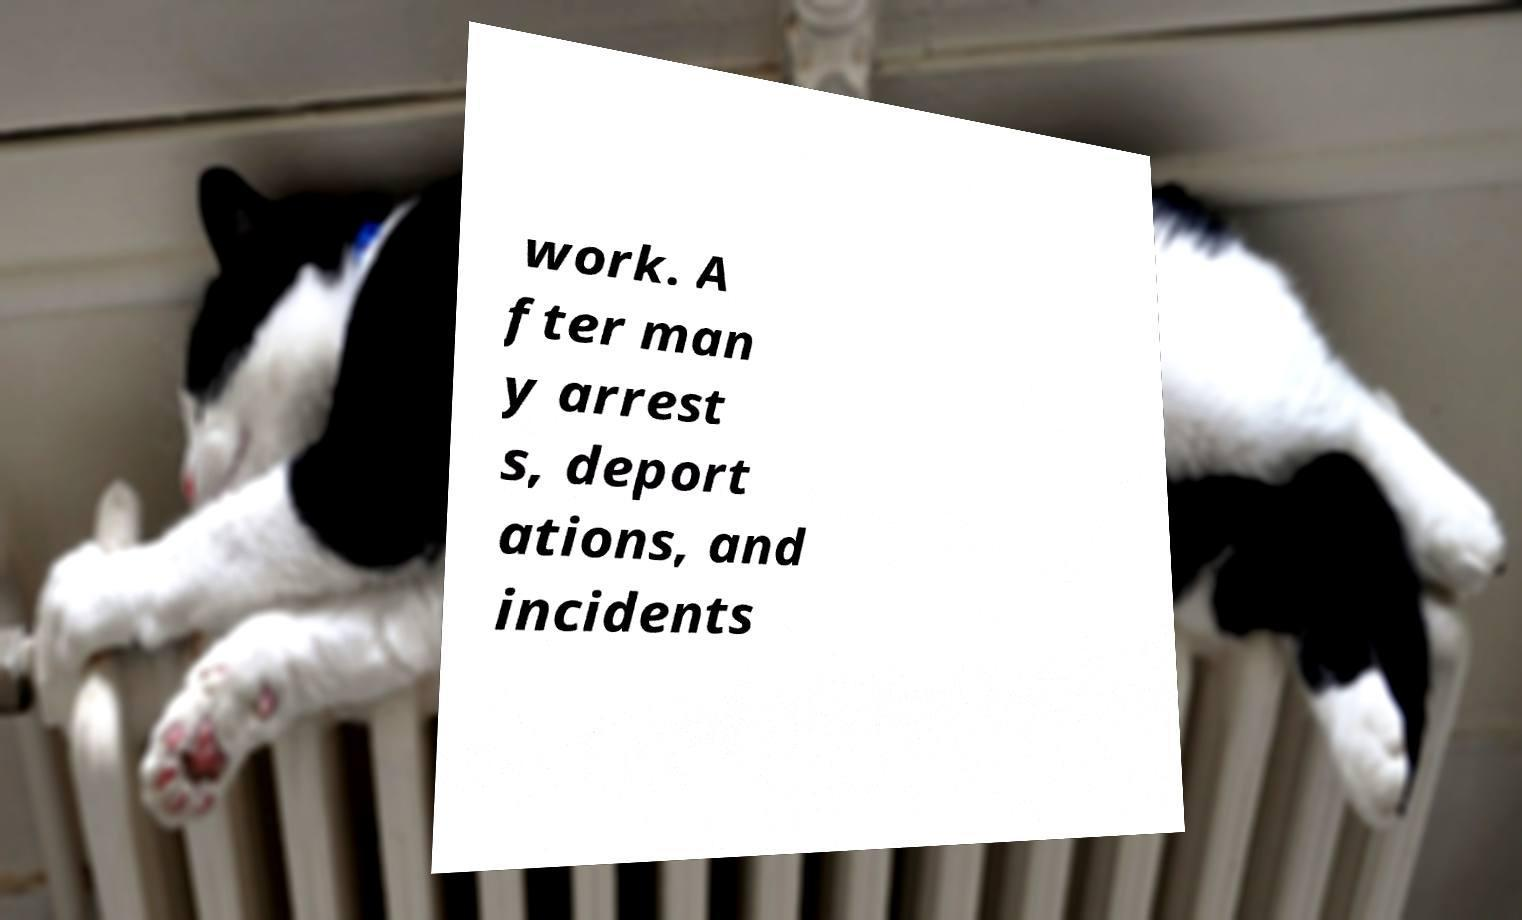Please identify and transcribe the text found in this image. work. A fter man y arrest s, deport ations, and incidents 